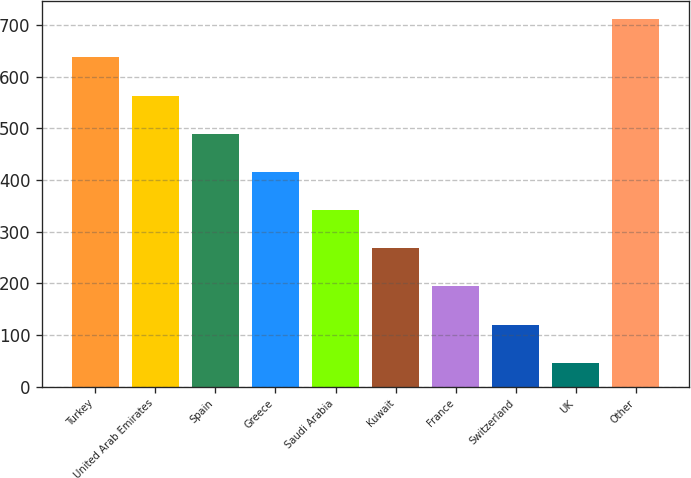Convert chart. <chart><loc_0><loc_0><loc_500><loc_500><bar_chart><fcel>Turkey<fcel>United Arab Emirates<fcel>Spain<fcel>Greece<fcel>Saudi Arabia<fcel>Kuwait<fcel>France<fcel>Switzerland<fcel>UK<fcel>Other<nl><fcel>637.2<fcel>563.3<fcel>489.4<fcel>415.5<fcel>341.6<fcel>267.7<fcel>193.8<fcel>119.9<fcel>46<fcel>711.1<nl></chart> 